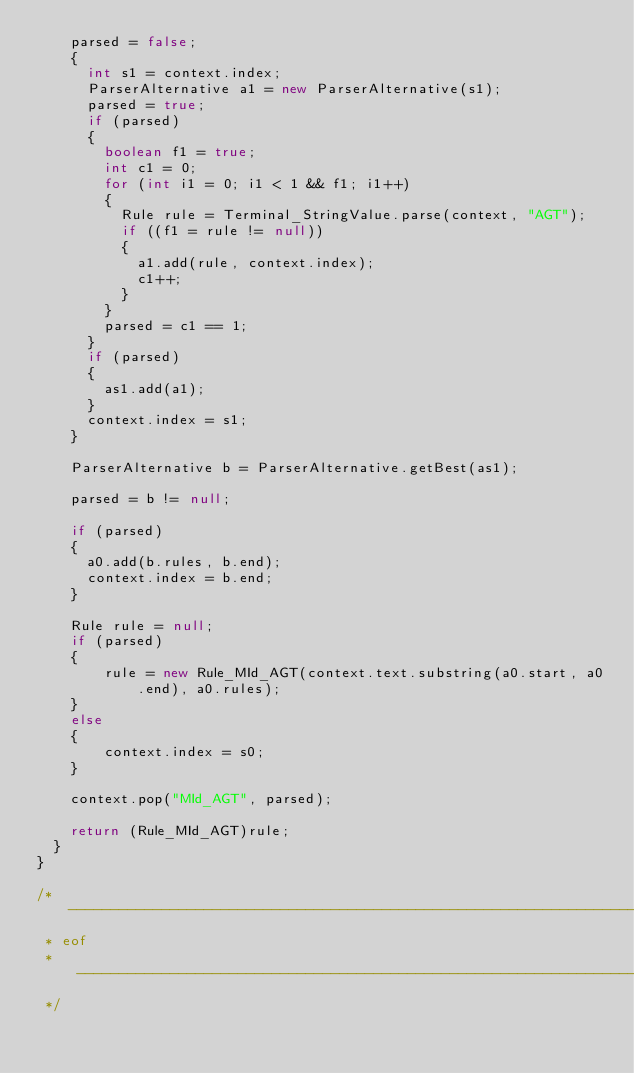<code> <loc_0><loc_0><loc_500><loc_500><_Java_>    parsed = false;
    {
      int s1 = context.index;
      ParserAlternative a1 = new ParserAlternative(s1);
      parsed = true;
      if (parsed)
      {
        boolean f1 = true;
        int c1 = 0;
        for (int i1 = 0; i1 < 1 && f1; i1++)
        {
          Rule rule = Terminal_StringValue.parse(context, "AGT");
          if ((f1 = rule != null))
          {
            a1.add(rule, context.index);
            c1++;
          }
        }
        parsed = c1 == 1;
      }
      if (parsed)
      {
        as1.add(a1);
      }
      context.index = s1;
    }

    ParserAlternative b = ParserAlternative.getBest(as1);

    parsed = b != null;

    if (parsed)
    {
      a0.add(b.rules, b.end);
      context.index = b.end;
    }

    Rule rule = null;
    if (parsed)
    {
        rule = new Rule_MId_AGT(context.text.substring(a0.start, a0.end), a0.rules);
    }
    else
    {
        context.index = s0;
    }

    context.pop("MId_AGT", parsed);

    return (Rule_MId_AGT)rule;
  }
}

/* -----------------------------------------------------------------------------
 * eof
 * -----------------------------------------------------------------------------
 */
</code> 